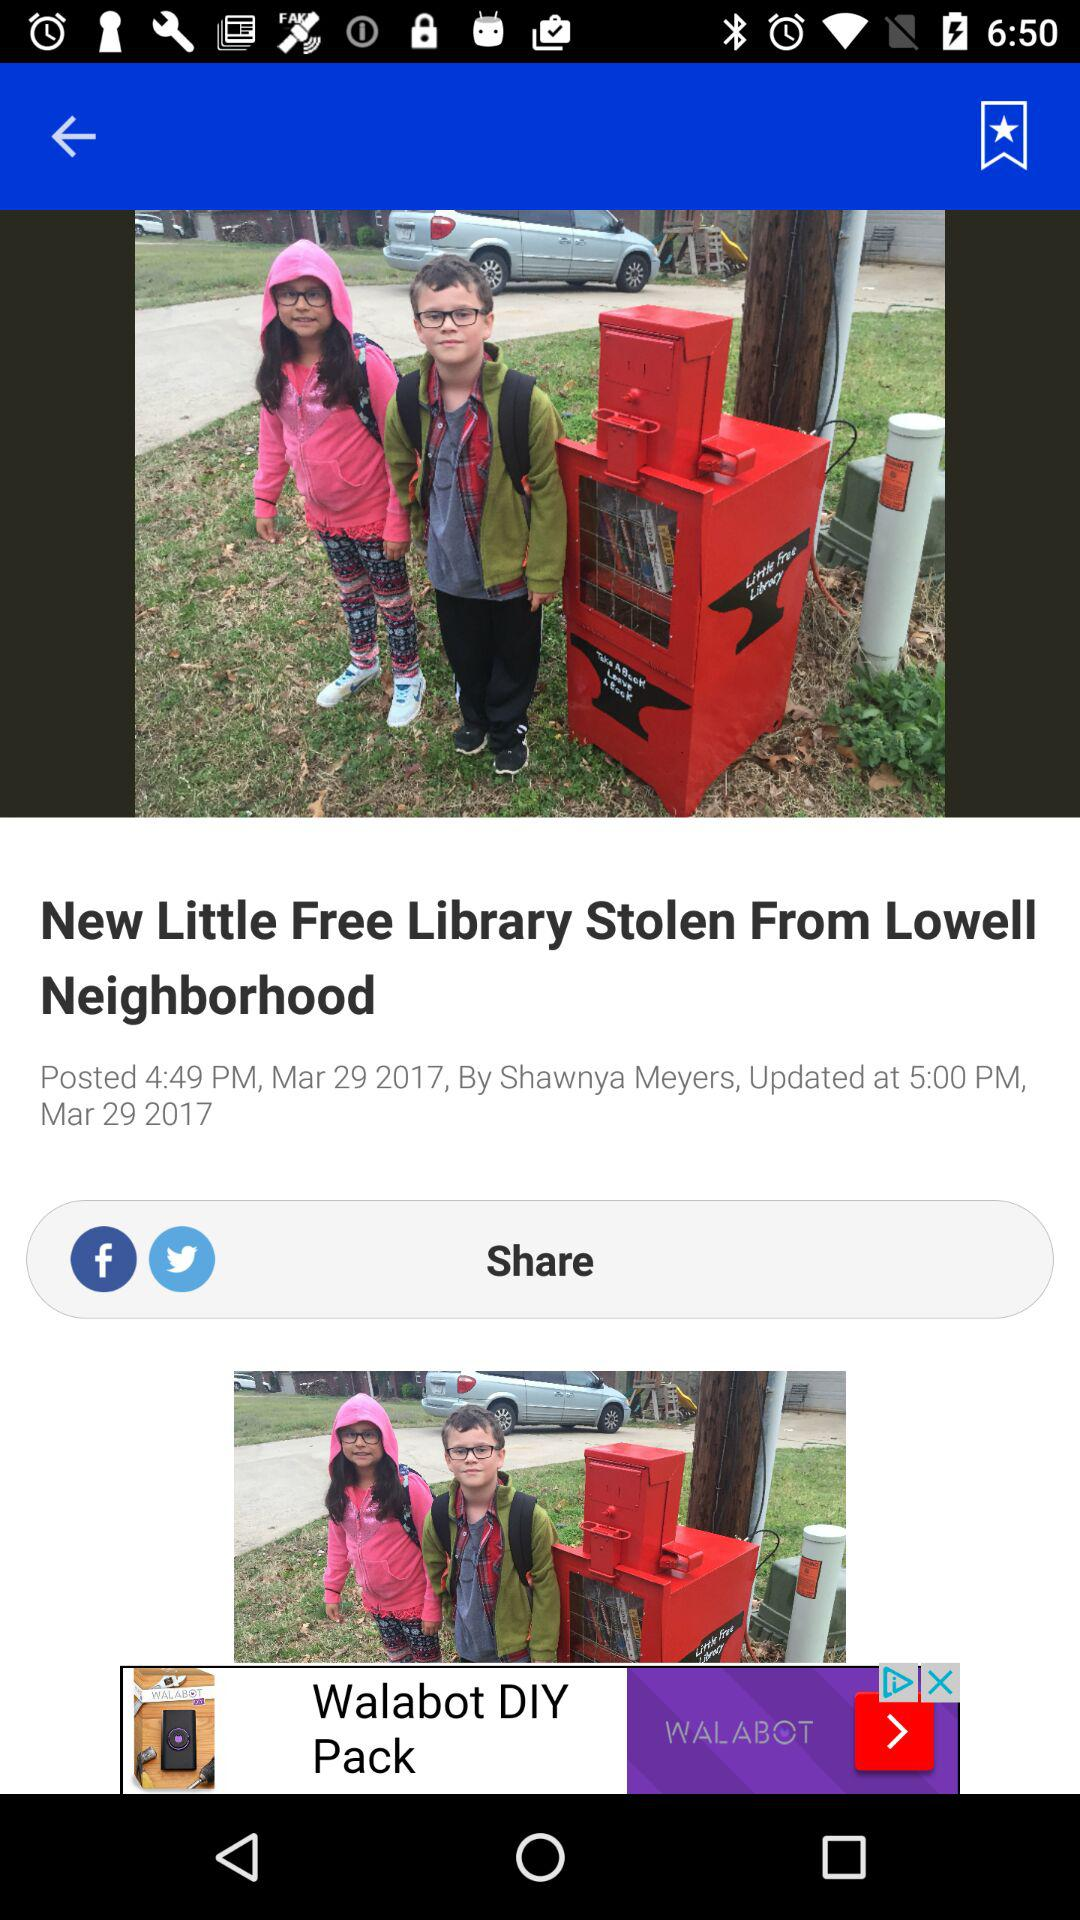What is the posted time of the article? The posted time of the article is 4:49 p.m. 